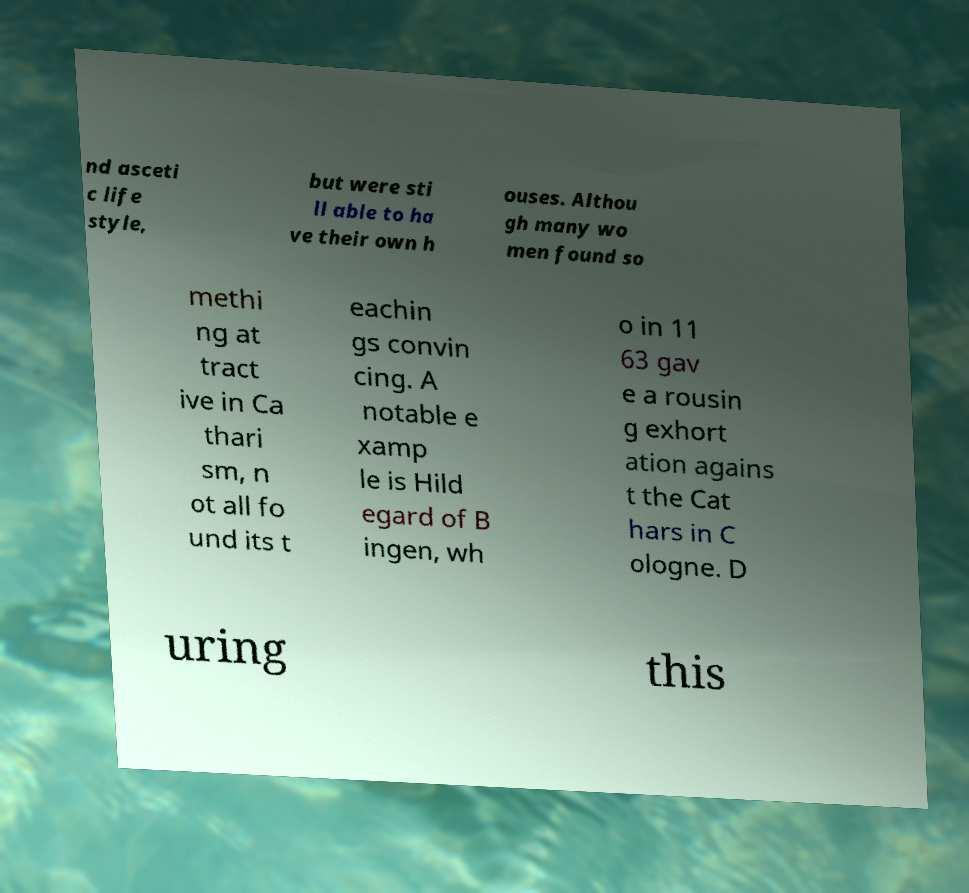There's text embedded in this image that I need extracted. Can you transcribe it verbatim? nd asceti c life style, but were sti ll able to ha ve their own h ouses. Althou gh many wo men found so methi ng at tract ive in Ca thari sm, n ot all fo und its t eachin gs convin cing. A notable e xamp le is Hild egard of B ingen, wh o in 11 63 gav e a rousin g exhort ation agains t the Cat hars in C ologne. D uring this 